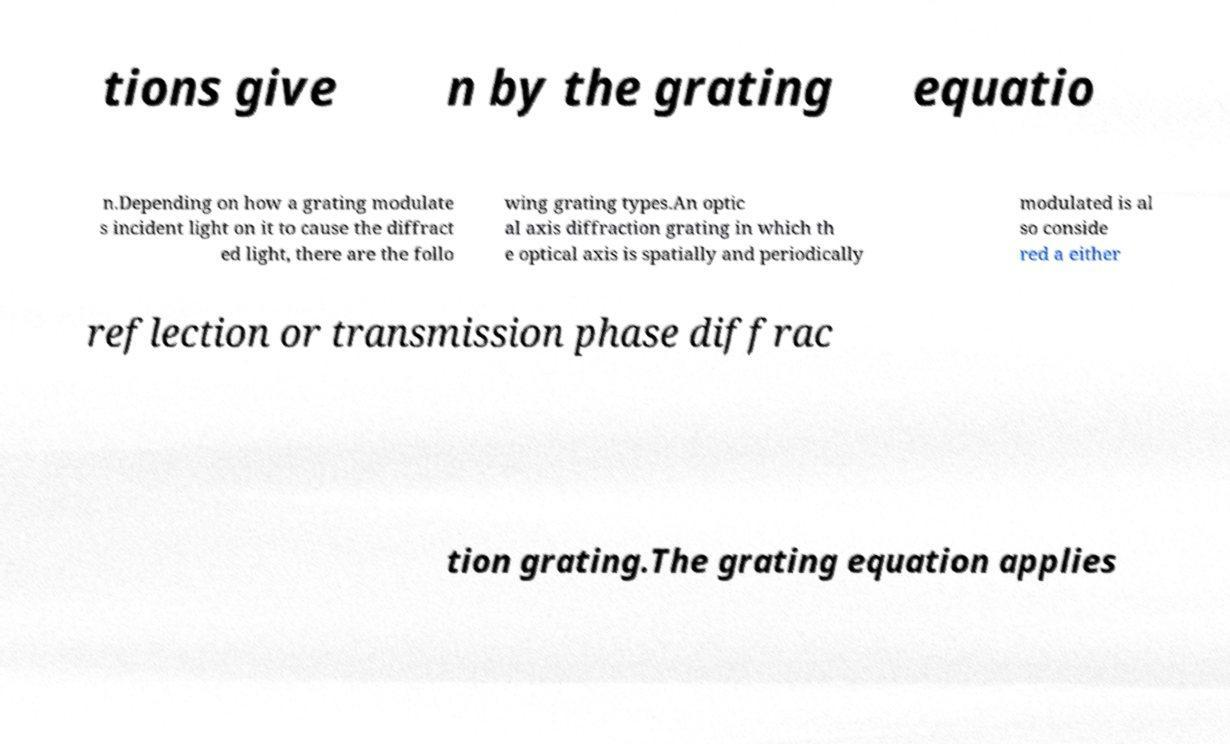Could you extract and type out the text from this image? tions give n by the grating equatio n.Depending on how a grating modulate s incident light on it to cause the diffract ed light, there are the follo wing grating types.An optic al axis diffraction grating in which th e optical axis is spatially and periodically modulated is al so conside red a either reflection or transmission phase diffrac tion grating.The grating equation applies 